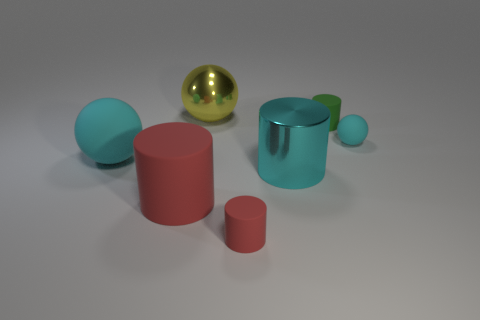Is there anything else that has the same material as the tiny green object?
Provide a succinct answer. Yes. There is a metal cylinder that is the same color as the large rubber ball; what is its size?
Your answer should be compact. Large. Are there any large yellow balls made of the same material as the big yellow object?
Offer a very short reply. No. There is a cylinder on the left side of the small red rubber thing; what is its material?
Give a very brief answer. Rubber. There is a matte ball behind the big rubber ball; does it have the same color as the tiny cylinder right of the small red matte cylinder?
Offer a very short reply. No. The metal object that is the same size as the metal sphere is what color?
Ensure brevity in your answer.  Cyan. How many other objects are the same shape as the large yellow object?
Offer a very short reply. 2. What size is the cyan rubber object left of the big red rubber cylinder?
Make the answer very short. Large. There is a matte sphere that is on the left side of the green matte cylinder; how many tiny cyan matte balls are behind it?
Offer a terse response. 1. What number of other objects are the same size as the shiny cylinder?
Keep it short and to the point. 3. 